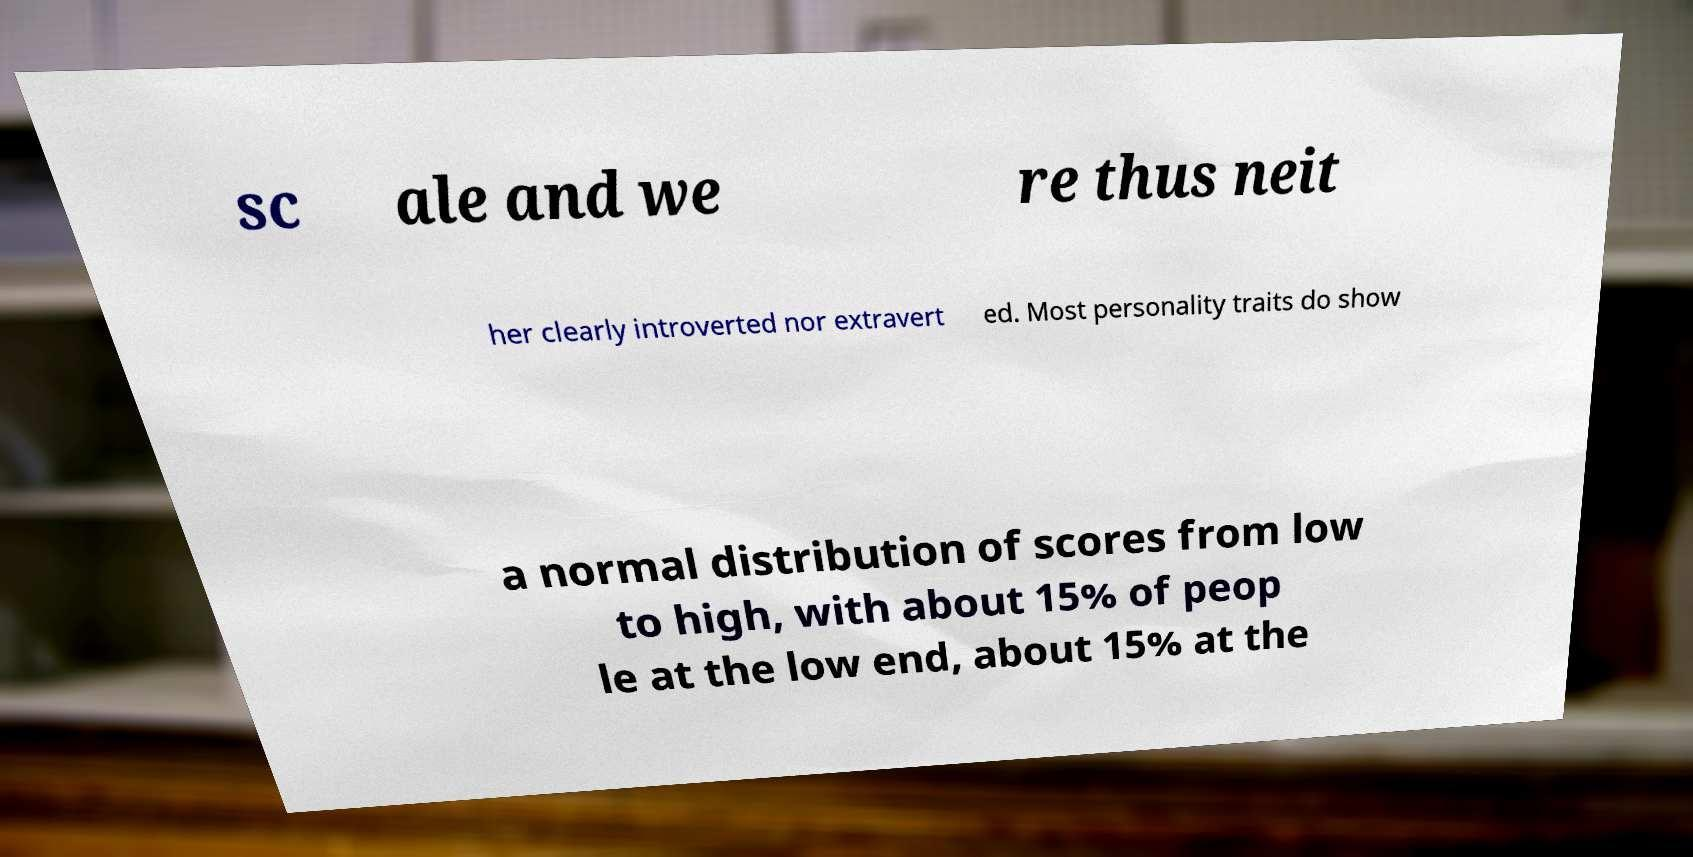I need the written content from this picture converted into text. Can you do that? sc ale and we re thus neit her clearly introverted nor extravert ed. Most personality traits do show a normal distribution of scores from low to high, with about 15% of peop le at the low end, about 15% at the 